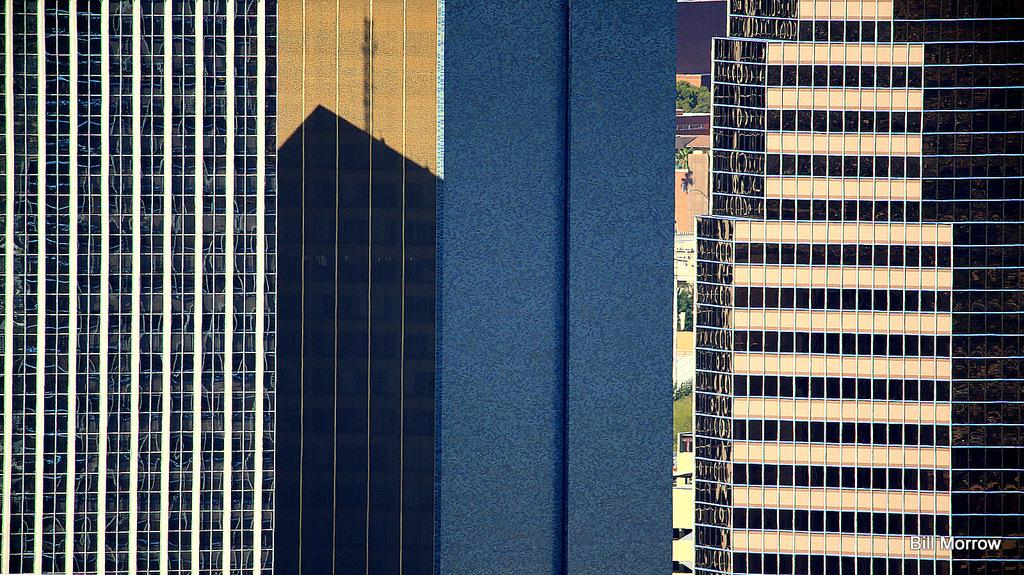What type of structures can be seen in the image? There are buildings in the image. What is located in the center of the image? There are plants in the center of the image. What type of vegetation is present on the ground in the image? There is grass on the ground in the image. Where is the text located in the image? The text is in the bottom right corner of the image. Are there any giant berries visible in the image? There are no berries, giant or otherwise, present in the image. 